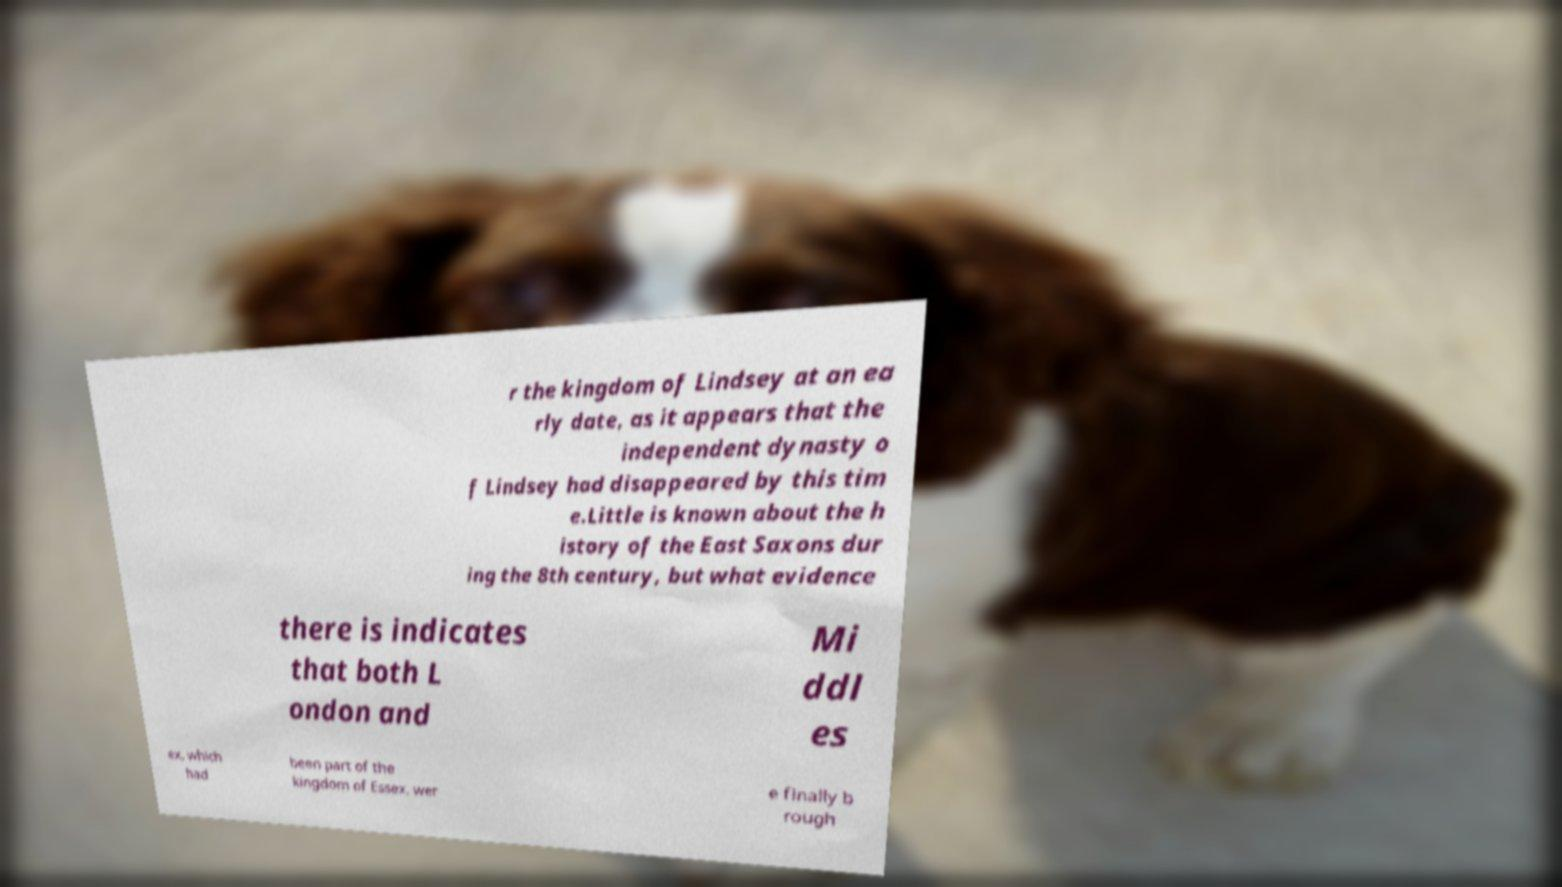I need the written content from this picture converted into text. Can you do that? r the kingdom of Lindsey at an ea rly date, as it appears that the independent dynasty o f Lindsey had disappeared by this tim e.Little is known about the h istory of the East Saxons dur ing the 8th century, but what evidence there is indicates that both L ondon and Mi ddl es ex, which had been part of the kingdom of Essex, wer e finally b rough 